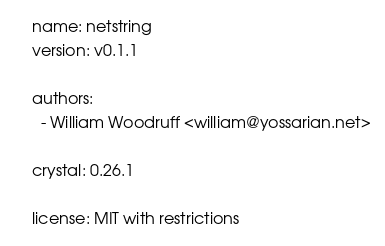<code> <loc_0><loc_0><loc_500><loc_500><_YAML_>name: netstring
version: v0.1.1

authors:
  - William Woodruff <william@yossarian.net>

crystal: 0.26.1

license: MIT with restrictions
</code> 